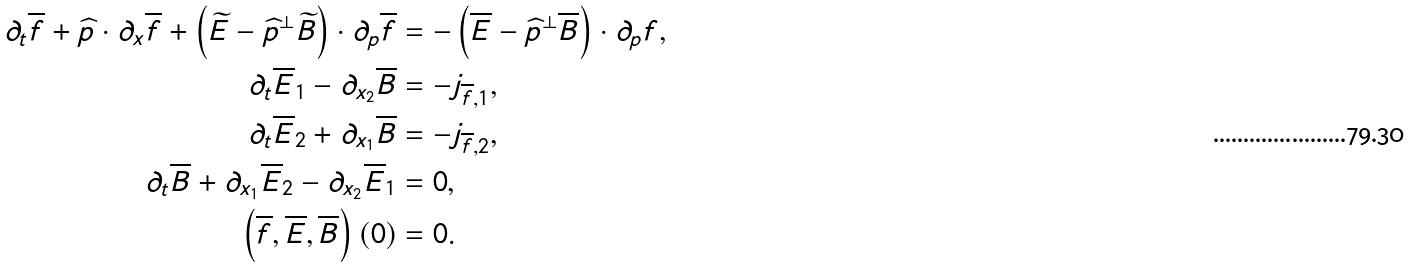Convert formula to latex. <formula><loc_0><loc_0><loc_500><loc_500>\partial _ { t } \overline { f } + \widehat { p } \cdot \partial _ { x } \overline { f } + \left ( \widetilde { E } - \widehat { p } ^ { \bot } \widetilde { B } \right ) \cdot \partial _ { p } \overline { f } & = - \left ( \overline { E } - \widehat { p } ^ { \bot } \overline { B } \right ) \cdot \partial _ { p } f , \\ \partial _ { t } \overline { E } _ { 1 } - \partial _ { x _ { 2 } } \overline { B } & = - j _ { \overline { f } , 1 } , \\ \partial _ { t } \overline { E } _ { 2 } + \partial _ { x _ { 1 } } \overline { B } & = - j _ { \overline { f } , 2 } , \\ \partial _ { t } \overline { B } + \partial _ { x _ { 1 } } \overline { E } _ { 2 } - \partial _ { x _ { 2 } } \overline { E } _ { 1 } & = 0 , \\ \left ( \overline { f } , \overline { E } , \overline { B } \right ) \left ( 0 \right ) & = 0 .</formula> 